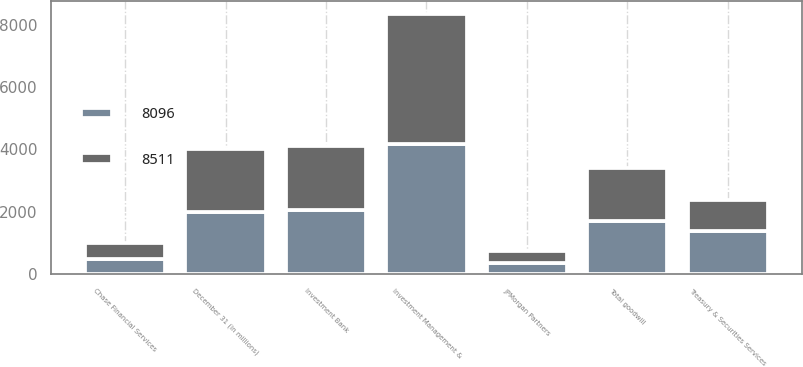Convert chart to OTSL. <chart><loc_0><loc_0><loc_500><loc_500><stacked_bar_chart><ecel><fcel>December 31 (in millions)<fcel>Investment Bank<fcel>Treasury & Securities Services<fcel>Investment Management &<fcel>JPMorgan Partners<fcel>Chase Financial Services<fcel>Total goodwill<nl><fcel>8096<fcel>2003<fcel>2058<fcel>1390<fcel>4179<fcel>377<fcel>507<fcel>1696<nl><fcel>8511<fcel>2002<fcel>2051<fcel>996<fcel>4165<fcel>377<fcel>507<fcel>1696<nl></chart> 